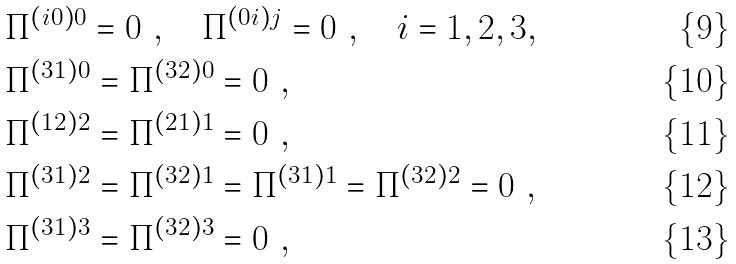Convert formula to latex. <formula><loc_0><loc_0><loc_500><loc_500>& \Pi ^ { \left ( i 0 \right ) 0 } = 0 \ , \quad \Pi ^ { \left ( 0 i \right ) j } = 0 \ , \quad i = 1 , 2 , 3 , \\ & \Pi ^ { ( 3 1 ) 0 } = \Pi ^ { ( 3 2 ) 0 } = 0 \ , \\ & \Pi ^ { ( 1 2 ) 2 } = \Pi ^ { ( 2 1 ) 1 } = 0 \ , \\ & \Pi ^ { ( 3 1 ) 2 } = \Pi ^ { ( 3 2 ) 1 } = \Pi ^ { ( 3 1 ) 1 } = \Pi ^ { ( 3 2 ) 2 } = 0 \ , \\ & \Pi ^ { ( 3 1 ) 3 } = \Pi ^ { ( 3 2 ) 3 } = 0 \ ,</formula> 